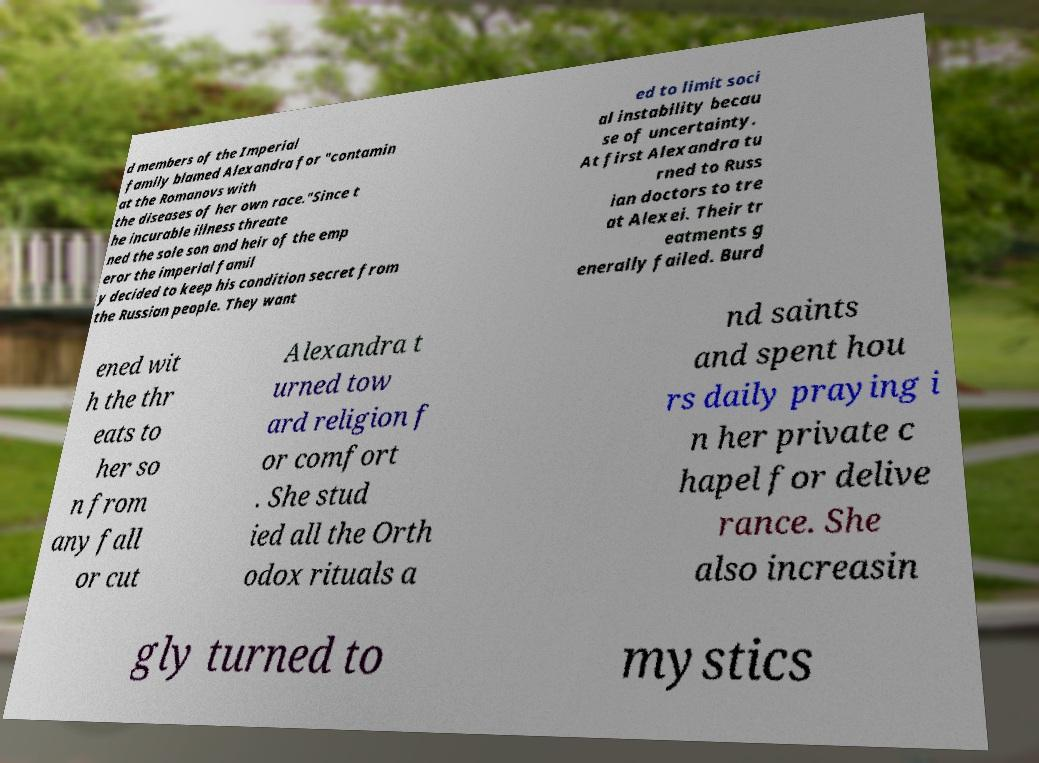Please read and relay the text visible in this image. What does it say? d members of the Imperial family blamed Alexandra for "contamin at the Romanovs with the diseases of her own race."Since t he incurable illness threate ned the sole son and heir of the emp eror the imperial famil y decided to keep his condition secret from the Russian people. They want ed to limit soci al instability becau se of uncertainty. At first Alexandra tu rned to Russ ian doctors to tre at Alexei. Their tr eatments g enerally failed. Burd ened wit h the thr eats to her so n from any fall or cut Alexandra t urned tow ard religion f or comfort . She stud ied all the Orth odox rituals a nd saints and spent hou rs daily praying i n her private c hapel for delive rance. She also increasin gly turned to mystics 